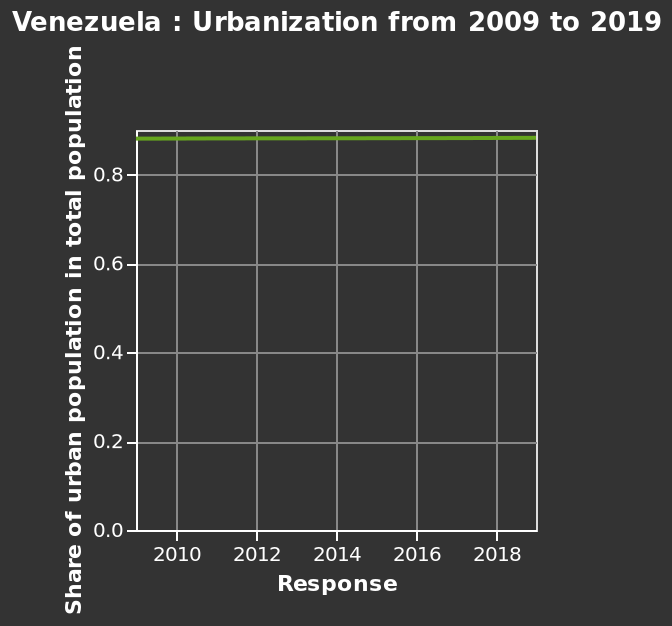<image>
What is the percentage of the urban population in the total population in 2019?  The percentage of the urban population in the total population remains the same between 2009 and 2019. What is plotted on the x-axis of the graph? The x-axis plots "Response" with a linear scale from 2010 to 2018. Is there a difference in the urban population share between 2009 and 2019?  No, there is no difference in the urban population share between 2009 and 2019. 